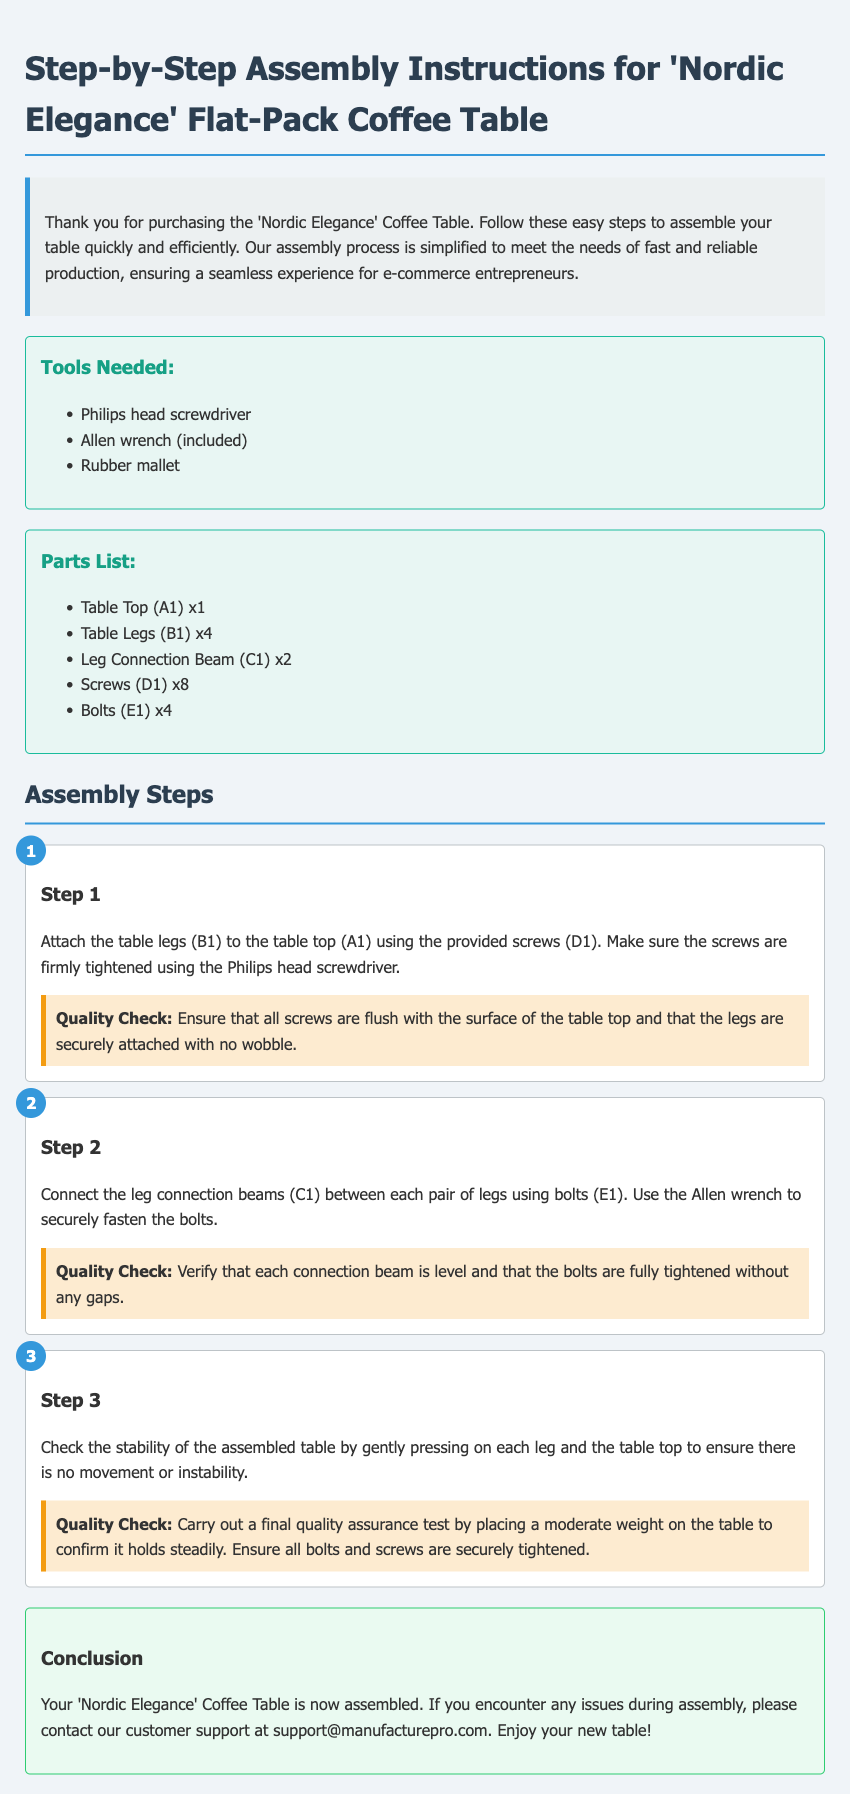What tools are needed for assembly? The document lists the specific tools required for assembly, which are three types: a Philips head screwdriver, an Allen wrench, and a rubber mallet.
Answer: Philips head screwdriver, Allen wrench, rubber mallet How many legs does the coffee table have? The parts list clearly states that there are four table legs labeled as (B1).
Answer: 4 What is the first step in the assembly process? The first step in the assembly process involves attaching the table legs to the table top using screws.
Answer: Attach the table legs to the table top What should be checked during the quality assurance for Step 2? The quality check for Step 2 requires verification that each connection beam is level and that the bolts are fully tightened without any gaps.
Answer: Verify that each connection beam is level What does the customer support email address provide? The document includes a customer support email address for assistance if issues arise during assembly.
Answer: support@manufacturepro.com How many screws are included in the parts list? According to the parts list, there are a total of eight screws labeled as (D1).
Answer: 8 